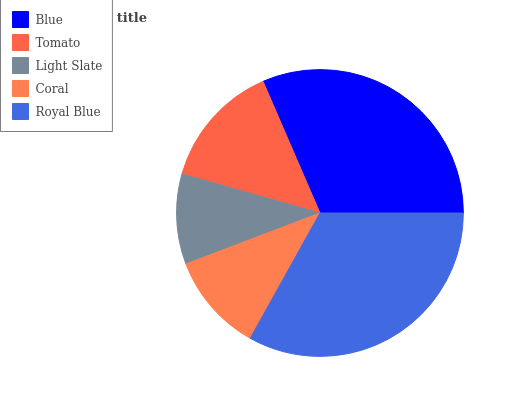Is Light Slate the minimum?
Answer yes or no. Yes. Is Royal Blue the maximum?
Answer yes or no. Yes. Is Tomato the minimum?
Answer yes or no. No. Is Tomato the maximum?
Answer yes or no. No. Is Blue greater than Tomato?
Answer yes or no. Yes. Is Tomato less than Blue?
Answer yes or no. Yes. Is Tomato greater than Blue?
Answer yes or no. No. Is Blue less than Tomato?
Answer yes or no. No. Is Tomato the high median?
Answer yes or no. Yes. Is Tomato the low median?
Answer yes or no. Yes. Is Blue the high median?
Answer yes or no. No. Is Coral the low median?
Answer yes or no. No. 